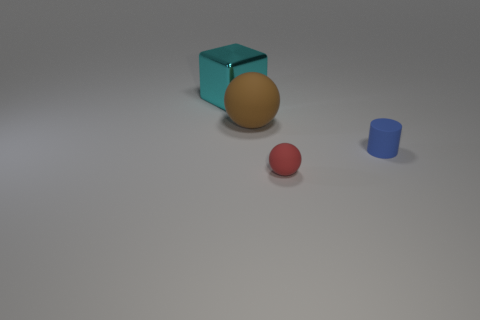Add 3 small blue rubber cylinders. How many objects exist? 7 Subtract all cylinders. How many objects are left? 3 Add 4 small matte balls. How many small matte balls are left? 5 Add 2 red rubber spheres. How many red rubber spheres exist? 3 Subtract 0 purple cylinders. How many objects are left? 4 Subtract all big things. Subtract all red balls. How many objects are left? 1 